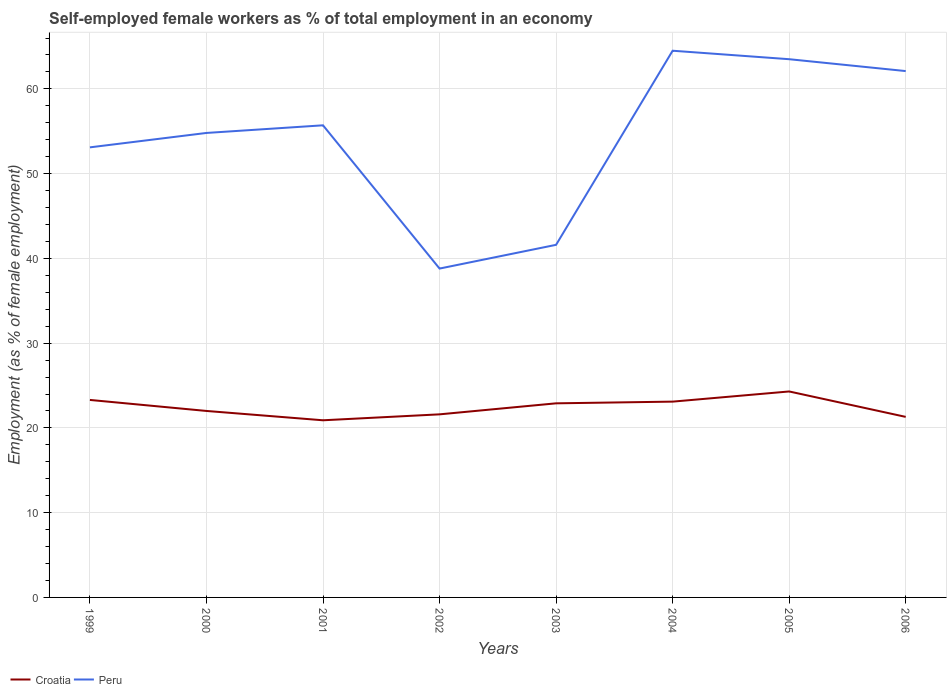Across all years, what is the maximum percentage of self-employed female workers in Croatia?
Make the answer very short. 20.9. In which year was the percentage of self-employed female workers in Peru maximum?
Give a very brief answer. 2002. What is the total percentage of self-employed female workers in Croatia in the graph?
Ensure brevity in your answer.  0.4. What is the difference between the highest and the second highest percentage of self-employed female workers in Peru?
Offer a terse response. 25.7. Is the percentage of self-employed female workers in Croatia strictly greater than the percentage of self-employed female workers in Peru over the years?
Your answer should be very brief. Yes. How many lines are there?
Provide a succinct answer. 2. How many years are there in the graph?
Offer a very short reply. 8. Are the values on the major ticks of Y-axis written in scientific E-notation?
Keep it short and to the point. No. Where does the legend appear in the graph?
Ensure brevity in your answer.  Bottom left. What is the title of the graph?
Provide a succinct answer. Self-employed female workers as % of total employment in an economy. Does "French Polynesia" appear as one of the legend labels in the graph?
Offer a terse response. No. What is the label or title of the X-axis?
Offer a very short reply. Years. What is the label or title of the Y-axis?
Provide a succinct answer. Employment (as % of female employment). What is the Employment (as % of female employment) in Croatia in 1999?
Offer a terse response. 23.3. What is the Employment (as % of female employment) in Peru in 1999?
Your response must be concise. 53.1. What is the Employment (as % of female employment) of Croatia in 2000?
Your answer should be very brief. 22. What is the Employment (as % of female employment) in Peru in 2000?
Your answer should be very brief. 54.8. What is the Employment (as % of female employment) of Croatia in 2001?
Your answer should be compact. 20.9. What is the Employment (as % of female employment) of Peru in 2001?
Your answer should be compact. 55.7. What is the Employment (as % of female employment) in Croatia in 2002?
Ensure brevity in your answer.  21.6. What is the Employment (as % of female employment) in Peru in 2002?
Provide a succinct answer. 38.8. What is the Employment (as % of female employment) of Croatia in 2003?
Ensure brevity in your answer.  22.9. What is the Employment (as % of female employment) of Peru in 2003?
Provide a succinct answer. 41.6. What is the Employment (as % of female employment) of Croatia in 2004?
Give a very brief answer. 23.1. What is the Employment (as % of female employment) in Peru in 2004?
Your answer should be very brief. 64.5. What is the Employment (as % of female employment) of Croatia in 2005?
Your answer should be very brief. 24.3. What is the Employment (as % of female employment) of Peru in 2005?
Keep it short and to the point. 63.5. What is the Employment (as % of female employment) in Croatia in 2006?
Make the answer very short. 21.3. What is the Employment (as % of female employment) of Peru in 2006?
Your answer should be compact. 62.1. Across all years, what is the maximum Employment (as % of female employment) in Croatia?
Your answer should be compact. 24.3. Across all years, what is the maximum Employment (as % of female employment) of Peru?
Your answer should be compact. 64.5. Across all years, what is the minimum Employment (as % of female employment) of Croatia?
Your answer should be very brief. 20.9. Across all years, what is the minimum Employment (as % of female employment) in Peru?
Provide a succinct answer. 38.8. What is the total Employment (as % of female employment) in Croatia in the graph?
Provide a short and direct response. 179.4. What is the total Employment (as % of female employment) in Peru in the graph?
Your response must be concise. 434.1. What is the difference between the Employment (as % of female employment) of Croatia in 1999 and that in 2002?
Provide a succinct answer. 1.7. What is the difference between the Employment (as % of female employment) in Peru in 1999 and that in 2002?
Give a very brief answer. 14.3. What is the difference between the Employment (as % of female employment) of Peru in 1999 and that in 2003?
Your answer should be very brief. 11.5. What is the difference between the Employment (as % of female employment) in Croatia in 1999 and that in 2004?
Make the answer very short. 0.2. What is the difference between the Employment (as % of female employment) of Peru in 1999 and that in 2004?
Make the answer very short. -11.4. What is the difference between the Employment (as % of female employment) in Croatia in 1999 and that in 2005?
Your response must be concise. -1. What is the difference between the Employment (as % of female employment) in Croatia in 1999 and that in 2006?
Make the answer very short. 2. What is the difference between the Employment (as % of female employment) in Croatia in 2000 and that in 2001?
Offer a very short reply. 1.1. What is the difference between the Employment (as % of female employment) in Peru in 2000 and that in 2002?
Your response must be concise. 16. What is the difference between the Employment (as % of female employment) in Croatia in 2000 and that in 2003?
Keep it short and to the point. -0.9. What is the difference between the Employment (as % of female employment) of Peru in 2000 and that in 2003?
Your response must be concise. 13.2. What is the difference between the Employment (as % of female employment) of Croatia in 2000 and that in 2005?
Provide a short and direct response. -2.3. What is the difference between the Employment (as % of female employment) of Peru in 2000 and that in 2005?
Offer a terse response. -8.7. What is the difference between the Employment (as % of female employment) of Croatia in 2000 and that in 2006?
Ensure brevity in your answer.  0.7. What is the difference between the Employment (as % of female employment) in Peru in 2000 and that in 2006?
Give a very brief answer. -7.3. What is the difference between the Employment (as % of female employment) of Croatia in 2001 and that in 2002?
Offer a terse response. -0.7. What is the difference between the Employment (as % of female employment) in Peru in 2001 and that in 2002?
Ensure brevity in your answer.  16.9. What is the difference between the Employment (as % of female employment) of Peru in 2001 and that in 2004?
Your response must be concise. -8.8. What is the difference between the Employment (as % of female employment) of Croatia in 2002 and that in 2003?
Keep it short and to the point. -1.3. What is the difference between the Employment (as % of female employment) of Peru in 2002 and that in 2003?
Offer a terse response. -2.8. What is the difference between the Employment (as % of female employment) in Croatia in 2002 and that in 2004?
Provide a succinct answer. -1.5. What is the difference between the Employment (as % of female employment) in Peru in 2002 and that in 2004?
Provide a succinct answer. -25.7. What is the difference between the Employment (as % of female employment) in Croatia in 2002 and that in 2005?
Provide a succinct answer. -2.7. What is the difference between the Employment (as % of female employment) of Peru in 2002 and that in 2005?
Your response must be concise. -24.7. What is the difference between the Employment (as % of female employment) in Croatia in 2002 and that in 2006?
Your answer should be compact. 0.3. What is the difference between the Employment (as % of female employment) in Peru in 2002 and that in 2006?
Give a very brief answer. -23.3. What is the difference between the Employment (as % of female employment) in Croatia in 2003 and that in 2004?
Your response must be concise. -0.2. What is the difference between the Employment (as % of female employment) in Peru in 2003 and that in 2004?
Your answer should be very brief. -22.9. What is the difference between the Employment (as % of female employment) of Croatia in 2003 and that in 2005?
Make the answer very short. -1.4. What is the difference between the Employment (as % of female employment) of Peru in 2003 and that in 2005?
Offer a very short reply. -21.9. What is the difference between the Employment (as % of female employment) in Peru in 2003 and that in 2006?
Give a very brief answer. -20.5. What is the difference between the Employment (as % of female employment) in Peru in 2004 and that in 2005?
Your answer should be very brief. 1. What is the difference between the Employment (as % of female employment) of Croatia in 2004 and that in 2006?
Your response must be concise. 1.8. What is the difference between the Employment (as % of female employment) in Peru in 2004 and that in 2006?
Your response must be concise. 2.4. What is the difference between the Employment (as % of female employment) of Croatia in 2005 and that in 2006?
Offer a terse response. 3. What is the difference between the Employment (as % of female employment) of Peru in 2005 and that in 2006?
Make the answer very short. 1.4. What is the difference between the Employment (as % of female employment) in Croatia in 1999 and the Employment (as % of female employment) in Peru in 2000?
Your answer should be very brief. -31.5. What is the difference between the Employment (as % of female employment) in Croatia in 1999 and the Employment (as % of female employment) in Peru in 2001?
Make the answer very short. -32.4. What is the difference between the Employment (as % of female employment) in Croatia in 1999 and the Employment (as % of female employment) in Peru in 2002?
Make the answer very short. -15.5. What is the difference between the Employment (as % of female employment) of Croatia in 1999 and the Employment (as % of female employment) of Peru in 2003?
Make the answer very short. -18.3. What is the difference between the Employment (as % of female employment) in Croatia in 1999 and the Employment (as % of female employment) in Peru in 2004?
Your response must be concise. -41.2. What is the difference between the Employment (as % of female employment) of Croatia in 1999 and the Employment (as % of female employment) of Peru in 2005?
Your answer should be very brief. -40.2. What is the difference between the Employment (as % of female employment) in Croatia in 1999 and the Employment (as % of female employment) in Peru in 2006?
Your response must be concise. -38.8. What is the difference between the Employment (as % of female employment) in Croatia in 2000 and the Employment (as % of female employment) in Peru in 2001?
Your answer should be compact. -33.7. What is the difference between the Employment (as % of female employment) of Croatia in 2000 and the Employment (as % of female employment) of Peru in 2002?
Offer a terse response. -16.8. What is the difference between the Employment (as % of female employment) of Croatia in 2000 and the Employment (as % of female employment) of Peru in 2003?
Ensure brevity in your answer.  -19.6. What is the difference between the Employment (as % of female employment) of Croatia in 2000 and the Employment (as % of female employment) of Peru in 2004?
Your answer should be compact. -42.5. What is the difference between the Employment (as % of female employment) in Croatia in 2000 and the Employment (as % of female employment) in Peru in 2005?
Make the answer very short. -41.5. What is the difference between the Employment (as % of female employment) in Croatia in 2000 and the Employment (as % of female employment) in Peru in 2006?
Make the answer very short. -40.1. What is the difference between the Employment (as % of female employment) of Croatia in 2001 and the Employment (as % of female employment) of Peru in 2002?
Offer a terse response. -17.9. What is the difference between the Employment (as % of female employment) of Croatia in 2001 and the Employment (as % of female employment) of Peru in 2003?
Ensure brevity in your answer.  -20.7. What is the difference between the Employment (as % of female employment) in Croatia in 2001 and the Employment (as % of female employment) in Peru in 2004?
Keep it short and to the point. -43.6. What is the difference between the Employment (as % of female employment) of Croatia in 2001 and the Employment (as % of female employment) of Peru in 2005?
Your answer should be compact. -42.6. What is the difference between the Employment (as % of female employment) in Croatia in 2001 and the Employment (as % of female employment) in Peru in 2006?
Provide a succinct answer. -41.2. What is the difference between the Employment (as % of female employment) in Croatia in 2002 and the Employment (as % of female employment) in Peru in 2004?
Offer a terse response. -42.9. What is the difference between the Employment (as % of female employment) in Croatia in 2002 and the Employment (as % of female employment) in Peru in 2005?
Your response must be concise. -41.9. What is the difference between the Employment (as % of female employment) in Croatia in 2002 and the Employment (as % of female employment) in Peru in 2006?
Keep it short and to the point. -40.5. What is the difference between the Employment (as % of female employment) in Croatia in 2003 and the Employment (as % of female employment) in Peru in 2004?
Provide a short and direct response. -41.6. What is the difference between the Employment (as % of female employment) of Croatia in 2003 and the Employment (as % of female employment) of Peru in 2005?
Offer a terse response. -40.6. What is the difference between the Employment (as % of female employment) of Croatia in 2003 and the Employment (as % of female employment) of Peru in 2006?
Provide a succinct answer. -39.2. What is the difference between the Employment (as % of female employment) of Croatia in 2004 and the Employment (as % of female employment) of Peru in 2005?
Give a very brief answer. -40.4. What is the difference between the Employment (as % of female employment) of Croatia in 2004 and the Employment (as % of female employment) of Peru in 2006?
Keep it short and to the point. -39. What is the difference between the Employment (as % of female employment) of Croatia in 2005 and the Employment (as % of female employment) of Peru in 2006?
Make the answer very short. -37.8. What is the average Employment (as % of female employment) of Croatia per year?
Ensure brevity in your answer.  22.43. What is the average Employment (as % of female employment) in Peru per year?
Provide a succinct answer. 54.26. In the year 1999, what is the difference between the Employment (as % of female employment) in Croatia and Employment (as % of female employment) in Peru?
Ensure brevity in your answer.  -29.8. In the year 2000, what is the difference between the Employment (as % of female employment) in Croatia and Employment (as % of female employment) in Peru?
Offer a very short reply. -32.8. In the year 2001, what is the difference between the Employment (as % of female employment) of Croatia and Employment (as % of female employment) of Peru?
Ensure brevity in your answer.  -34.8. In the year 2002, what is the difference between the Employment (as % of female employment) in Croatia and Employment (as % of female employment) in Peru?
Keep it short and to the point. -17.2. In the year 2003, what is the difference between the Employment (as % of female employment) in Croatia and Employment (as % of female employment) in Peru?
Your response must be concise. -18.7. In the year 2004, what is the difference between the Employment (as % of female employment) of Croatia and Employment (as % of female employment) of Peru?
Make the answer very short. -41.4. In the year 2005, what is the difference between the Employment (as % of female employment) of Croatia and Employment (as % of female employment) of Peru?
Your answer should be compact. -39.2. In the year 2006, what is the difference between the Employment (as % of female employment) in Croatia and Employment (as % of female employment) in Peru?
Offer a terse response. -40.8. What is the ratio of the Employment (as % of female employment) of Croatia in 1999 to that in 2000?
Provide a short and direct response. 1.06. What is the ratio of the Employment (as % of female employment) in Peru in 1999 to that in 2000?
Provide a succinct answer. 0.97. What is the ratio of the Employment (as % of female employment) in Croatia in 1999 to that in 2001?
Your response must be concise. 1.11. What is the ratio of the Employment (as % of female employment) in Peru in 1999 to that in 2001?
Keep it short and to the point. 0.95. What is the ratio of the Employment (as % of female employment) of Croatia in 1999 to that in 2002?
Make the answer very short. 1.08. What is the ratio of the Employment (as % of female employment) of Peru in 1999 to that in 2002?
Offer a terse response. 1.37. What is the ratio of the Employment (as % of female employment) in Croatia in 1999 to that in 2003?
Your answer should be compact. 1.02. What is the ratio of the Employment (as % of female employment) of Peru in 1999 to that in 2003?
Your answer should be very brief. 1.28. What is the ratio of the Employment (as % of female employment) of Croatia in 1999 to that in 2004?
Your answer should be very brief. 1.01. What is the ratio of the Employment (as % of female employment) in Peru in 1999 to that in 2004?
Your answer should be compact. 0.82. What is the ratio of the Employment (as % of female employment) in Croatia in 1999 to that in 2005?
Provide a short and direct response. 0.96. What is the ratio of the Employment (as % of female employment) in Peru in 1999 to that in 2005?
Your response must be concise. 0.84. What is the ratio of the Employment (as % of female employment) of Croatia in 1999 to that in 2006?
Make the answer very short. 1.09. What is the ratio of the Employment (as % of female employment) of Peru in 1999 to that in 2006?
Ensure brevity in your answer.  0.86. What is the ratio of the Employment (as % of female employment) in Croatia in 2000 to that in 2001?
Offer a terse response. 1.05. What is the ratio of the Employment (as % of female employment) in Peru in 2000 to that in 2001?
Your answer should be very brief. 0.98. What is the ratio of the Employment (as % of female employment) of Croatia in 2000 to that in 2002?
Your answer should be compact. 1.02. What is the ratio of the Employment (as % of female employment) of Peru in 2000 to that in 2002?
Keep it short and to the point. 1.41. What is the ratio of the Employment (as % of female employment) of Croatia in 2000 to that in 2003?
Your answer should be very brief. 0.96. What is the ratio of the Employment (as % of female employment) in Peru in 2000 to that in 2003?
Your response must be concise. 1.32. What is the ratio of the Employment (as % of female employment) of Croatia in 2000 to that in 2004?
Keep it short and to the point. 0.95. What is the ratio of the Employment (as % of female employment) in Peru in 2000 to that in 2004?
Provide a short and direct response. 0.85. What is the ratio of the Employment (as % of female employment) in Croatia in 2000 to that in 2005?
Ensure brevity in your answer.  0.91. What is the ratio of the Employment (as % of female employment) in Peru in 2000 to that in 2005?
Provide a short and direct response. 0.86. What is the ratio of the Employment (as % of female employment) in Croatia in 2000 to that in 2006?
Offer a very short reply. 1.03. What is the ratio of the Employment (as % of female employment) in Peru in 2000 to that in 2006?
Give a very brief answer. 0.88. What is the ratio of the Employment (as % of female employment) of Croatia in 2001 to that in 2002?
Give a very brief answer. 0.97. What is the ratio of the Employment (as % of female employment) in Peru in 2001 to that in 2002?
Make the answer very short. 1.44. What is the ratio of the Employment (as % of female employment) in Croatia in 2001 to that in 2003?
Give a very brief answer. 0.91. What is the ratio of the Employment (as % of female employment) of Peru in 2001 to that in 2003?
Your answer should be compact. 1.34. What is the ratio of the Employment (as % of female employment) of Croatia in 2001 to that in 2004?
Provide a short and direct response. 0.9. What is the ratio of the Employment (as % of female employment) of Peru in 2001 to that in 2004?
Offer a terse response. 0.86. What is the ratio of the Employment (as % of female employment) in Croatia in 2001 to that in 2005?
Ensure brevity in your answer.  0.86. What is the ratio of the Employment (as % of female employment) of Peru in 2001 to that in 2005?
Make the answer very short. 0.88. What is the ratio of the Employment (as % of female employment) in Croatia in 2001 to that in 2006?
Offer a very short reply. 0.98. What is the ratio of the Employment (as % of female employment) in Peru in 2001 to that in 2006?
Make the answer very short. 0.9. What is the ratio of the Employment (as % of female employment) in Croatia in 2002 to that in 2003?
Make the answer very short. 0.94. What is the ratio of the Employment (as % of female employment) in Peru in 2002 to that in 2003?
Provide a short and direct response. 0.93. What is the ratio of the Employment (as % of female employment) of Croatia in 2002 to that in 2004?
Provide a short and direct response. 0.94. What is the ratio of the Employment (as % of female employment) in Peru in 2002 to that in 2004?
Make the answer very short. 0.6. What is the ratio of the Employment (as % of female employment) in Croatia in 2002 to that in 2005?
Offer a very short reply. 0.89. What is the ratio of the Employment (as % of female employment) in Peru in 2002 to that in 2005?
Provide a short and direct response. 0.61. What is the ratio of the Employment (as % of female employment) in Croatia in 2002 to that in 2006?
Give a very brief answer. 1.01. What is the ratio of the Employment (as % of female employment) of Peru in 2002 to that in 2006?
Offer a terse response. 0.62. What is the ratio of the Employment (as % of female employment) in Peru in 2003 to that in 2004?
Your answer should be compact. 0.65. What is the ratio of the Employment (as % of female employment) of Croatia in 2003 to that in 2005?
Ensure brevity in your answer.  0.94. What is the ratio of the Employment (as % of female employment) of Peru in 2003 to that in 2005?
Give a very brief answer. 0.66. What is the ratio of the Employment (as % of female employment) in Croatia in 2003 to that in 2006?
Your answer should be very brief. 1.08. What is the ratio of the Employment (as % of female employment) of Peru in 2003 to that in 2006?
Your answer should be very brief. 0.67. What is the ratio of the Employment (as % of female employment) in Croatia in 2004 to that in 2005?
Offer a terse response. 0.95. What is the ratio of the Employment (as % of female employment) of Peru in 2004 to that in 2005?
Offer a terse response. 1.02. What is the ratio of the Employment (as % of female employment) in Croatia in 2004 to that in 2006?
Offer a very short reply. 1.08. What is the ratio of the Employment (as % of female employment) of Peru in 2004 to that in 2006?
Your answer should be compact. 1.04. What is the ratio of the Employment (as % of female employment) of Croatia in 2005 to that in 2006?
Offer a terse response. 1.14. What is the ratio of the Employment (as % of female employment) in Peru in 2005 to that in 2006?
Offer a very short reply. 1.02. What is the difference between the highest and the second highest Employment (as % of female employment) in Croatia?
Provide a short and direct response. 1. What is the difference between the highest and the second highest Employment (as % of female employment) in Peru?
Provide a succinct answer. 1. What is the difference between the highest and the lowest Employment (as % of female employment) of Peru?
Make the answer very short. 25.7. 